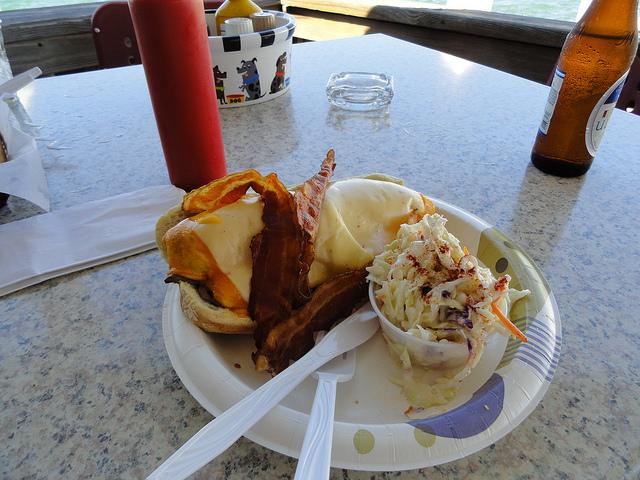Is it cole slaw?
Concise answer only. Yes. What kind of bottle is to the right?
Short answer required. Beer. Is it a fancy restaurant?
Concise answer only. No. 